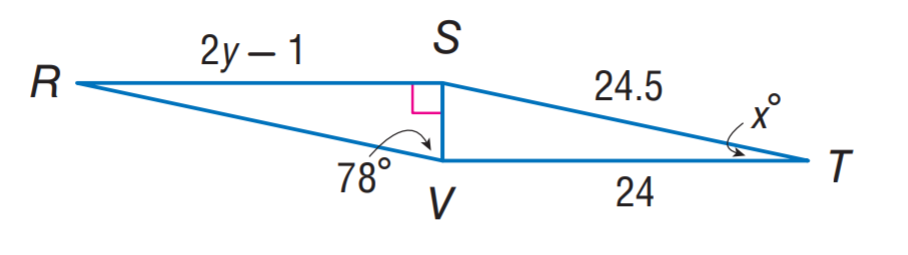Answer the mathemtical geometry problem and directly provide the correct option letter.
Question: \triangle R S V \cong \triangle T V S. Find y.
Choices: A: 11 B: 11.5 C: 12 D: 12.5 D 